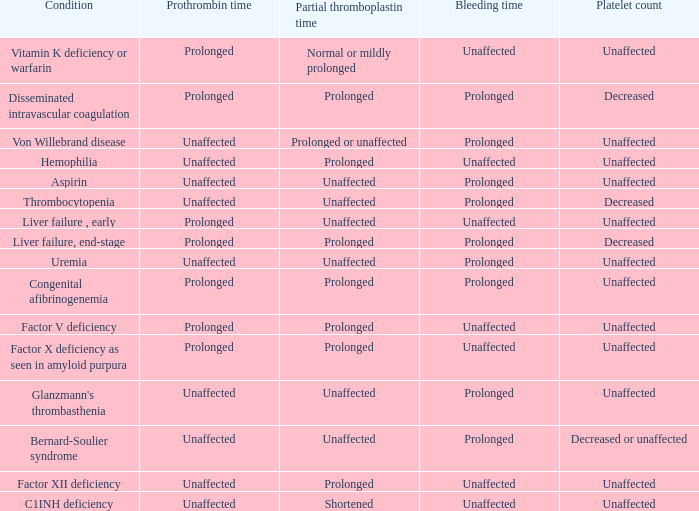What is the duration of bleeding in hemophilia? Unaffected. Could you parse the entire table? {'header': ['Condition', 'Prothrombin time', 'Partial thromboplastin time', 'Bleeding time', 'Platelet count'], 'rows': [['Vitamin K deficiency or warfarin', 'Prolonged', 'Normal or mildly prolonged', 'Unaffected', 'Unaffected'], ['Disseminated intravascular coagulation', 'Prolonged', 'Prolonged', 'Prolonged', 'Decreased'], ['Von Willebrand disease', 'Unaffected', 'Prolonged or unaffected', 'Prolonged', 'Unaffected'], ['Hemophilia', 'Unaffected', 'Prolonged', 'Unaffected', 'Unaffected'], ['Aspirin', 'Unaffected', 'Unaffected', 'Prolonged', 'Unaffected'], ['Thrombocytopenia', 'Unaffected', 'Unaffected', 'Prolonged', 'Decreased'], ['Liver failure , early', 'Prolonged', 'Unaffected', 'Unaffected', 'Unaffected'], ['Liver failure, end-stage', 'Prolonged', 'Prolonged', 'Prolonged', 'Decreased'], ['Uremia', 'Unaffected', 'Unaffected', 'Prolonged', 'Unaffected'], ['Congenital afibrinogenemia', 'Prolonged', 'Prolonged', 'Prolonged', 'Unaffected'], ['Factor V deficiency', 'Prolonged', 'Prolonged', 'Unaffected', 'Unaffected'], ['Factor X deficiency as seen in amyloid purpura', 'Prolonged', 'Prolonged', 'Unaffected', 'Unaffected'], ["Glanzmann's thrombasthenia", 'Unaffected', 'Unaffected', 'Prolonged', 'Unaffected'], ['Bernard-Soulier syndrome', 'Unaffected', 'Unaffected', 'Prolonged', 'Decreased or unaffected'], ['Factor XII deficiency', 'Unaffected', 'Prolonged', 'Unaffected', 'Unaffected'], ['C1INH deficiency', 'Unaffected', 'Shortened', 'Unaffected', 'Unaffected']]} 